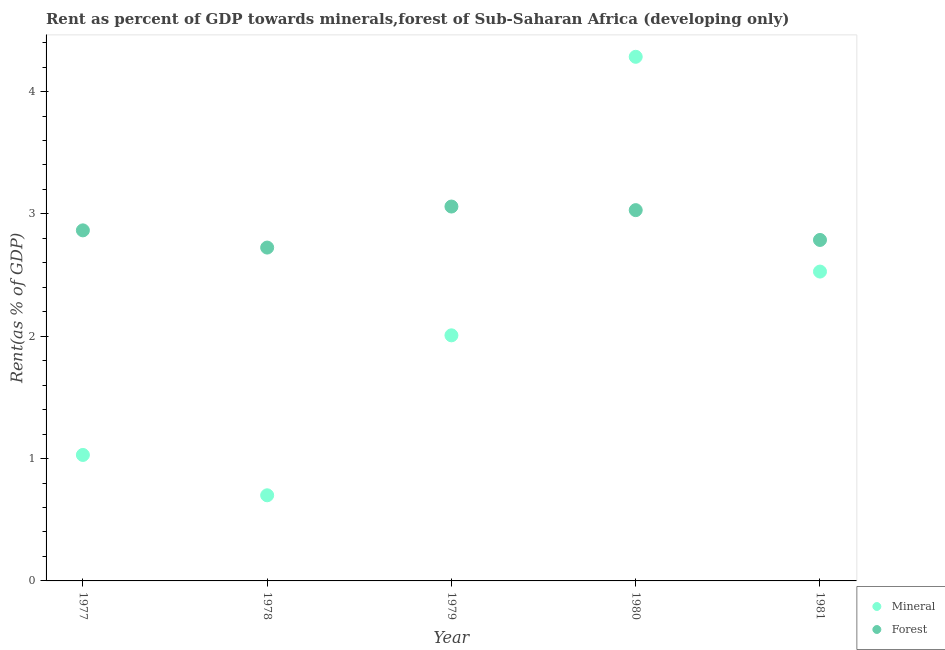What is the mineral rent in 1979?
Keep it short and to the point. 2.01. Across all years, what is the maximum mineral rent?
Offer a terse response. 4.28. Across all years, what is the minimum forest rent?
Provide a short and direct response. 2.72. In which year was the mineral rent minimum?
Keep it short and to the point. 1978. What is the total forest rent in the graph?
Make the answer very short. 14.47. What is the difference between the mineral rent in 1978 and that in 1980?
Offer a very short reply. -3.58. What is the difference between the forest rent in 1979 and the mineral rent in 1981?
Offer a very short reply. 0.53. What is the average mineral rent per year?
Your response must be concise. 2.11. In the year 1981, what is the difference between the mineral rent and forest rent?
Your answer should be very brief. -0.26. What is the ratio of the mineral rent in 1978 to that in 1980?
Keep it short and to the point. 0.16. What is the difference between the highest and the second highest forest rent?
Your answer should be compact. 0.03. What is the difference between the highest and the lowest mineral rent?
Offer a very short reply. 3.58. In how many years, is the forest rent greater than the average forest rent taken over all years?
Offer a very short reply. 2. Is the sum of the mineral rent in 1977 and 1981 greater than the maximum forest rent across all years?
Your response must be concise. Yes. Is the forest rent strictly greater than the mineral rent over the years?
Provide a succinct answer. No. Is the forest rent strictly less than the mineral rent over the years?
Offer a terse response. No. How many years are there in the graph?
Provide a short and direct response. 5. What is the difference between two consecutive major ticks on the Y-axis?
Give a very brief answer. 1. Are the values on the major ticks of Y-axis written in scientific E-notation?
Give a very brief answer. No. Does the graph contain any zero values?
Your answer should be compact. No. How are the legend labels stacked?
Offer a very short reply. Vertical. What is the title of the graph?
Offer a terse response. Rent as percent of GDP towards minerals,forest of Sub-Saharan Africa (developing only). Does "Primary education" appear as one of the legend labels in the graph?
Your response must be concise. No. What is the label or title of the Y-axis?
Your answer should be compact. Rent(as % of GDP). What is the Rent(as % of GDP) of Mineral in 1977?
Offer a terse response. 1.03. What is the Rent(as % of GDP) of Forest in 1977?
Provide a short and direct response. 2.87. What is the Rent(as % of GDP) of Mineral in 1978?
Keep it short and to the point. 0.7. What is the Rent(as % of GDP) in Forest in 1978?
Your answer should be compact. 2.72. What is the Rent(as % of GDP) of Mineral in 1979?
Your response must be concise. 2.01. What is the Rent(as % of GDP) in Forest in 1979?
Provide a short and direct response. 3.06. What is the Rent(as % of GDP) in Mineral in 1980?
Make the answer very short. 4.28. What is the Rent(as % of GDP) in Forest in 1980?
Your answer should be very brief. 3.03. What is the Rent(as % of GDP) in Mineral in 1981?
Provide a succinct answer. 2.53. What is the Rent(as % of GDP) in Forest in 1981?
Ensure brevity in your answer.  2.79. Across all years, what is the maximum Rent(as % of GDP) of Mineral?
Keep it short and to the point. 4.28. Across all years, what is the maximum Rent(as % of GDP) of Forest?
Provide a short and direct response. 3.06. Across all years, what is the minimum Rent(as % of GDP) of Mineral?
Your answer should be compact. 0.7. Across all years, what is the minimum Rent(as % of GDP) in Forest?
Provide a short and direct response. 2.72. What is the total Rent(as % of GDP) of Mineral in the graph?
Make the answer very short. 10.55. What is the total Rent(as % of GDP) of Forest in the graph?
Offer a terse response. 14.47. What is the difference between the Rent(as % of GDP) of Mineral in 1977 and that in 1978?
Your answer should be compact. 0.33. What is the difference between the Rent(as % of GDP) of Forest in 1977 and that in 1978?
Offer a terse response. 0.14. What is the difference between the Rent(as % of GDP) in Mineral in 1977 and that in 1979?
Ensure brevity in your answer.  -0.98. What is the difference between the Rent(as % of GDP) of Forest in 1977 and that in 1979?
Keep it short and to the point. -0.19. What is the difference between the Rent(as % of GDP) of Mineral in 1977 and that in 1980?
Keep it short and to the point. -3.25. What is the difference between the Rent(as % of GDP) in Forest in 1977 and that in 1980?
Ensure brevity in your answer.  -0.17. What is the difference between the Rent(as % of GDP) in Mineral in 1977 and that in 1981?
Keep it short and to the point. -1.5. What is the difference between the Rent(as % of GDP) in Forest in 1977 and that in 1981?
Provide a short and direct response. 0.08. What is the difference between the Rent(as % of GDP) of Mineral in 1978 and that in 1979?
Your answer should be compact. -1.31. What is the difference between the Rent(as % of GDP) of Forest in 1978 and that in 1979?
Ensure brevity in your answer.  -0.34. What is the difference between the Rent(as % of GDP) of Mineral in 1978 and that in 1980?
Make the answer very short. -3.58. What is the difference between the Rent(as % of GDP) of Forest in 1978 and that in 1980?
Your answer should be very brief. -0.31. What is the difference between the Rent(as % of GDP) in Mineral in 1978 and that in 1981?
Your response must be concise. -1.83. What is the difference between the Rent(as % of GDP) of Forest in 1978 and that in 1981?
Your answer should be very brief. -0.06. What is the difference between the Rent(as % of GDP) of Mineral in 1979 and that in 1980?
Your answer should be very brief. -2.28. What is the difference between the Rent(as % of GDP) of Forest in 1979 and that in 1980?
Keep it short and to the point. 0.03. What is the difference between the Rent(as % of GDP) in Mineral in 1979 and that in 1981?
Give a very brief answer. -0.52. What is the difference between the Rent(as % of GDP) of Forest in 1979 and that in 1981?
Provide a succinct answer. 0.27. What is the difference between the Rent(as % of GDP) in Mineral in 1980 and that in 1981?
Ensure brevity in your answer.  1.76. What is the difference between the Rent(as % of GDP) of Forest in 1980 and that in 1981?
Your response must be concise. 0.24. What is the difference between the Rent(as % of GDP) of Mineral in 1977 and the Rent(as % of GDP) of Forest in 1978?
Make the answer very short. -1.7. What is the difference between the Rent(as % of GDP) of Mineral in 1977 and the Rent(as % of GDP) of Forest in 1979?
Your answer should be very brief. -2.03. What is the difference between the Rent(as % of GDP) in Mineral in 1977 and the Rent(as % of GDP) in Forest in 1980?
Your answer should be compact. -2. What is the difference between the Rent(as % of GDP) of Mineral in 1977 and the Rent(as % of GDP) of Forest in 1981?
Your response must be concise. -1.76. What is the difference between the Rent(as % of GDP) in Mineral in 1978 and the Rent(as % of GDP) in Forest in 1979?
Offer a very short reply. -2.36. What is the difference between the Rent(as % of GDP) in Mineral in 1978 and the Rent(as % of GDP) in Forest in 1980?
Your answer should be compact. -2.33. What is the difference between the Rent(as % of GDP) of Mineral in 1978 and the Rent(as % of GDP) of Forest in 1981?
Give a very brief answer. -2.09. What is the difference between the Rent(as % of GDP) of Mineral in 1979 and the Rent(as % of GDP) of Forest in 1980?
Offer a very short reply. -1.02. What is the difference between the Rent(as % of GDP) of Mineral in 1979 and the Rent(as % of GDP) of Forest in 1981?
Your answer should be compact. -0.78. What is the difference between the Rent(as % of GDP) in Mineral in 1980 and the Rent(as % of GDP) in Forest in 1981?
Your answer should be very brief. 1.5. What is the average Rent(as % of GDP) of Mineral per year?
Offer a terse response. 2.11. What is the average Rent(as % of GDP) in Forest per year?
Provide a short and direct response. 2.89. In the year 1977, what is the difference between the Rent(as % of GDP) in Mineral and Rent(as % of GDP) in Forest?
Your answer should be very brief. -1.84. In the year 1978, what is the difference between the Rent(as % of GDP) in Mineral and Rent(as % of GDP) in Forest?
Give a very brief answer. -2.02. In the year 1979, what is the difference between the Rent(as % of GDP) in Mineral and Rent(as % of GDP) in Forest?
Your answer should be very brief. -1.05. In the year 1980, what is the difference between the Rent(as % of GDP) of Mineral and Rent(as % of GDP) of Forest?
Provide a short and direct response. 1.25. In the year 1981, what is the difference between the Rent(as % of GDP) in Mineral and Rent(as % of GDP) in Forest?
Your answer should be compact. -0.26. What is the ratio of the Rent(as % of GDP) in Mineral in 1977 to that in 1978?
Your answer should be compact. 1.47. What is the ratio of the Rent(as % of GDP) of Forest in 1977 to that in 1978?
Ensure brevity in your answer.  1.05. What is the ratio of the Rent(as % of GDP) in Mineral in 1977 to that in 1979?
Your response must be concise. 0.51. What is the ratio of the Rent(as % of GDP) of Forest in 1977 to that in 1979?
Your response must be concise. 0.94. What is the ratio of the Rent(as % of GDP) of Mineral in 1977 to that in 1980?
Offer a terse response. 0.24. What is the ratio of the Rent(as % of GDP) of Forest in 1977 to that in 1980?
Your response must be concise. 0.95. What is the ratio of the Rent(as % of GDP) of Mineral in 1977 to that in 1981?
Your answer should be very brief. 0.41. What is the ratio of the Rent(as % of GDP) of Forest in 1977 to that in 1981?
Your answer should be very brief. 1.03. What is the ratio of the Rent(as % of GDP) of Mineral in 1978 to that in 1979?
Provide a succinct answer. 0.35. What is the ratio of the Rent(as % of GDP) in Forest in 1978 to that in 1979?
Provide a succinct answer. 0.89. What is the ratio of the Rent(as % of GDP) in Mineral in 1978 to that in 1980?
Provide a succinct answer. 0.16. What is the ratio of the Rent(as % of GDP) of Forest in 1978 to that in 1980?
Offer a very short reply. 0.9. What is the ratio of the Rent(as % of GDP) in Mineral in 1978 to that in 1981?
Your answer should be compact. 0.28. What is the ratio of the Rent(as % of GDP) of Forest in 1978 to that in 1981?
Keep it short and to the point. 0.98. What is the ratio of the Rent(as % of GDP) of Mineral in 1979 to that in 1980?
Keep it short and to the point. 0.47. What is the ratio of the Rent(as % of GDP) of Forest in 1979 to that in 1980?
Your answer should be compact. 1.01. What is the ratio of the Rent(as % of GDP) of Mineral in 1979 to that in 1981?
Give a very brief answer. 0.79. What is the ratio of the Rent(as % of GDP) in Forest in 1979 to that in 1981?
Ensure brevity in your answer.  1.1. What is the ratio of the Rent(as % of GDP) in Mineral in 1980 to that in 1981?
Provide a succinct answer. 1.69. What is the ratio of the Rent(as % of GDP) in Forest in 1980 to that in 1981?
Offer a terse response. 1.09. What is the difference between the highest and the second highest Rent(as % of GDP) of Mineral?
Offer a very short reply. 1.76. What is the difference between the highest and the second highest Rent(as % of GDP) of Forest?
Offer a terse response. 0.03. What is the difference between the highest and the lowest Rent(as % of GDP) in Mineral?
Ensure brevity in your answer.  3.58. What is the difference between the highest and the lowest Rent(as % of GDP) of Forest?
Provide a short and direct response. 0.34. 